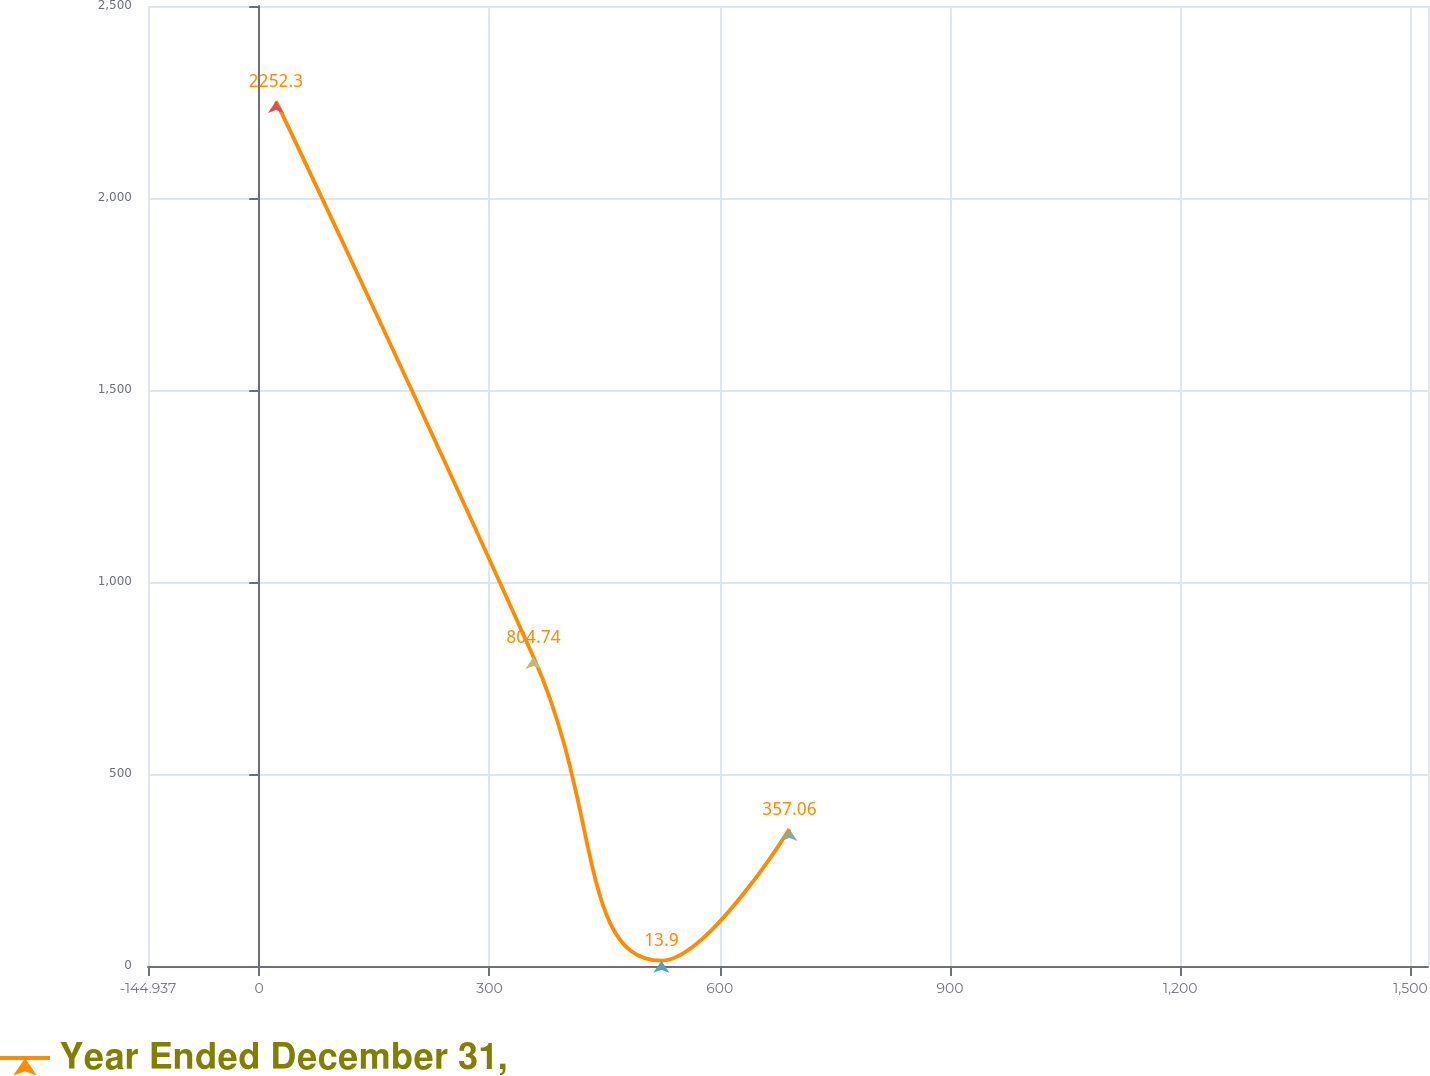Convert chart. <chart><loc_0><loc_0><loc_500><loc_500><line_chart><ecel><fcel>Year Ended December 31,<nl><fcel>21.84<fcel>2252.3<nl><fcel>357.27<fcel>804.74<nl><fcel>524.05<fcel>13.9<nl><fcel>690.83<fcel>357.06<nl><fcel>1689.61<fcel>580.9<nl></chart> 